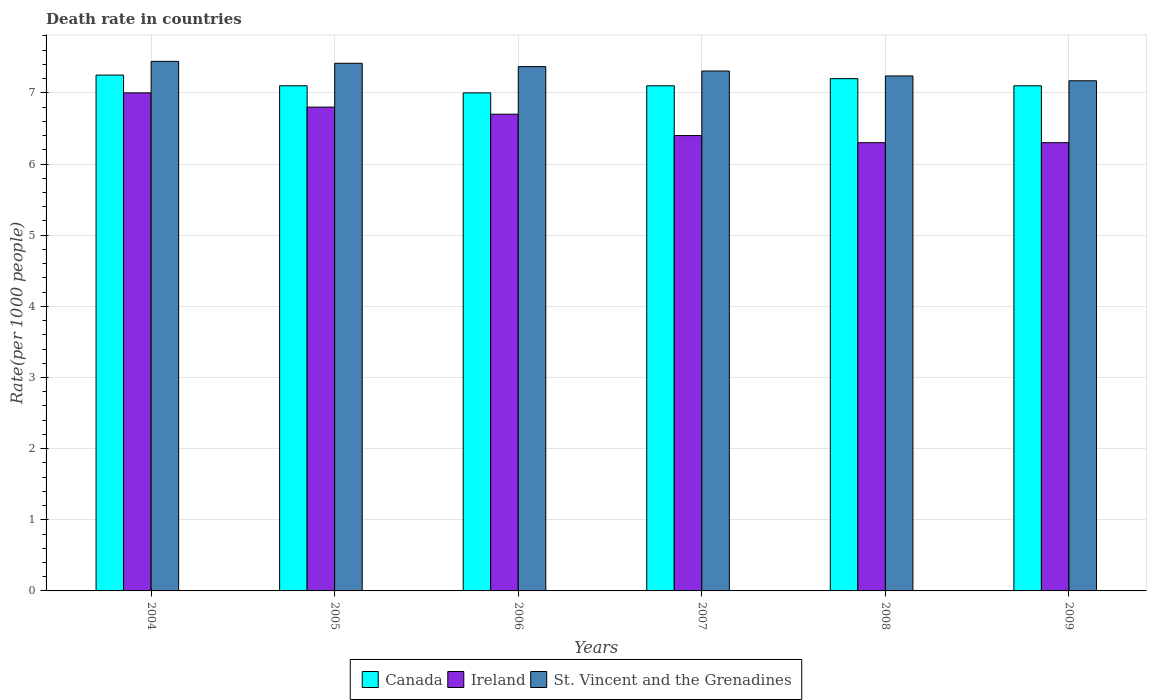How many different coloured bars are there?
Provide a short and direct response. 3. How many bars are there on the 2nd tick from the left?
Keep it short and to the point. 3. What is the death rate in St. Vincent and the Grenadines in 2007?
Make the answer very short. 7.31. In which year was the death rate in Canada minimum?
Your response must be concise. 2006. What is the total death rate in Canada in the graph?
Your answer should be compact. 42.75. What is the difference between the death rate in St. Vincent and the Grenadines in 2004 and that in 2007?
Provide a short and direct response. 0.14. What is the difference between the death rate in St. Vincent and the Grenadines in 2008 and the death rate in Canada in 2009?
Give a very brief answer. 0.14. What is the average death rate in St. Vincent and the Grenadines per year?
Offer a terse response. 7.32. In the year 2006, what is the difference between the death rate in St. Vincent and the Grenadines and death rate in Canada?
Offer a very short reply. 0.37. What is the ratio of the death rate in St. Vincent and the Grenadines in 2005 to that in 2009?
Offer a terse response. 1.03. Is the death rate in Canada in 2007 less than that in 2009?
Give a very brief answer. No. What is the difference between the highest and the second highest death rate in Ireland?
Your answer should be compact. 0.2. What is the difference between the highest and the lowest death rate in St. Vincent and the Grenadines?
Make the answer very short. 0.27. What does the 2nd bar from the left in 2009 represents?
Offer a very short reply. Ireland. What does the 2nd bar from the right in 2004 represents?
Your answer should be compact. Ireland. Are the values on the major ticks of Y-axis written in scientific E-notation?
Provide a succinct answer. No. Does the graph contain grids?
Ensure brevity in your answer.  Yes. How many legend labels are there?
Offer a very short reply. 3. How are the legend labels stacked?
Keep it short and to the point. Horizontal. What is the title of the graph?
Give a very brief answer. Death rate in countries. What is the label or title of the Y-axis?
Ensure brevity in your answer.  Rate(per 1000 people). What is the Rate(per 1000 people) in Canada in 2004?
Provide a short and direct response. 7.25. What is the Rate(per 1000 people) of St. Vincent and the Grenadines in 2004?
Offer a terse response. 7.44. What is the Rate(per 1000 people) in Canada in 2005?
Your response must be concise. 7.1. What is the Rate(per 1000 people) in St. Vincent and the Grenadines in 2005?
Offer a terse response. 7.42. What is the Rate(per 1000 people) in Ireland in 2006?
Offer a very short reply. 6.7. What is the Rate(per 1000 people) of St. Vincent and the Grenadines in 2006?
Offer a terse response. 7.37. What is the Rate(per 1000 people) in St. Vincent and the Grenadines in 2007?
Provide a succinct answer. 7.31. What is the Rate(per 1000 people) of Canada in 2008?
Provide a succinct answer. 7.2. What is the Rate(per 1000 people) in St. Vincent and the Grenadines in 2008?
Keep it short and to the point. 7.24. What is the Rate(per 1000 people) of Canada in 2009?
Provide a succinct answer. 7.1. What is the Rate(per 1000 people) of Ireland in 2009?
Provide a short and direct response. 6.3. What is the Rate(per 1000 people) of St. Vincent and the Grenadines in 2009?
Give a very brief answer. 7.17. Across all years, what is the maximum Rate(per 1000 people) of Canada?
Give a very brief answer. 7.25. Across all years, what is the maximum Rate(per 1000 people) in St. Vincent and the Grenadines?
Offer a terse response. 7.44. Across all years, what is the minimum Rate(per 1000 people) of St. Vincent and the Grenadines?
Give a very brief answer. 7.17. What is the total Rate(per 1000 people) in Canada in the graph?
Keep it short and to the point. 42.75. What is the total Rate(per 1000 people) in Ireland in the graph?
Your response must be concise. 39.5. What is the total Rate(per 1000 people) of St. Vincent and the Grenadines in the graph?
Your answer should be very brief. 43.94. What is the difference between the Rate(per 1000 people) in Ireland in 2004 and that in 2005?
Provide a short and direct response. 0.2. What is the difference between the Rate(per 1000 people) of St. Vincent and the Grenadines in 2004 and that in 2005?
Your answer should be very brief. 0.03. What is the difference between the Rate(per 1000 people) of St. Vincent and the Grenadines in 2004 and that in 2006?
Give a very brief answer. 0.07. What is the difference between the Rate(per 1000 people) of Canada in 2004 and that in 2007?
Your answer should be compact. 0.15. What is the difference between the Rate(per 1000 people) of St. Vincent and the Grenadines in 2004 and that in 2007?
Give a very brief answer. 0.14. What is the difference between the Rate(per 1000 people) of Canada in 2004 and that in 2008?
Your answer should be compact. 0.05. What is the difference between the Rate(per 1000 people) of St. Vincent and the Grenadines in 2004 and that in 2008?
Give a very brief answer. 0.2. What is the difference between the Rate(per 1000 people) in Canada in 2004 and that in 2009?
Provide a short and direct response. 0.15. What is the difference between the Rate(per 1000 people) in Ireland in 2004 and that in 2009?
Provide a succinct answer. 0.7. What is the difference between the Rate(per 1000 people) of St. Vincent and the Grenadines in 2004 and that in 2009?
Make the answer very short. 0.27. What is the difference between the Rate(per 1000 people) of Canada in 2005 and that in 2006?
Keep it short and to the point. 0.1. What is the difference between the Rate(per 1000 people) in St. Vincent and the Grenadines in 2005 and that in 2006?
Offer a very short reply. 0.05. What is the difference between the Rate(per 1000 people) in Canada in 2005 and that in 2007?
Offer a terse response. 0. What is the difference between the Rate(per 1000 people) of St. Vincent and the Grenadines in 2005 and that in 2007?
Give a very brief answer. 0.11. What is the difference between the Rate(per 1000 people) in St. Vincent and the Grenadines in 2005 and that in 2008?
Keep it short and to the point. 0.18. What is the difference between the Rate(per 1000 people) of St. Vincent and the Grenadines in 2005 and that in 2009?
Give a very brief answer. 0.25. What is the difference between the Rate(per 1000 people) in Ireland in 2006 and that in 2007?
Provide a succinct answer. 0.3. What is the difference between the Rate(per 1000 people) of St. Vincent and the Grenadines in 2006 and that in 2007?
Ensure brevity in your answer.  0.06. What is the difference between the Rate(per 1000 people) in Ireland in 2006 and that in 2008?
Offer a very short reply. 0.4. What is the difference between the Rate(per 1000 people) of St. Vincent and the Grenadines in 2006 and that in 2008?
Offer a terse response. 0.13. What is the difference between the Rate(per 1000 people) of St. Vincent and the Grenadines in 2006 and that in 2009?
Provide a short and direct response. 0.2. What is the difference between the Rate(per 1000 people) of Ireland in 2007 and that in 2008?
Make the answer very short. 0.1. What is the difference between the Rate(per 1000 people) in St. Vincent and the Grenadines in 2007 and that in 2008?
Offer a very short reply. 0.07. What is the difference between the Rate(per 1000 people) in Ireland in 2007 and that in 2009?
Ensure brevity in your answer.  0.1. What is the difference between the Rate(per 1000 people) in St. Vincent and the Grenadines in 2007 and that in 2009?
Make the answer very short. 0.14. What is the difference between the Rate(per 1000 people) in Canada in 2008 and that in 2009?
Give a very brief answer. 0.1. What is the difference between the Rate(per 1000 people) in Ireland in 2008 and that in 2009?
Provide a short and direct response. 0. What is the difference between the Rate(per 1000 people) of St. Vincent and the Grenadines in 2008 and that in 2009?
Give a very brief answer. 0.07. What is the difference between the Rate(per 1000 people) in Canada in 2004 and the Rate(per 1000 people) in Ireland in 2005?
Provide a succinct answer. 0.45. What is the difference between the Rate(per 1000 people) of Canada in 2004 and the Rate(per 1000 people) of St. Vincent and the Grenadines in 2005?
Your answer should be compact. -0.17. What is the difference between the Rate(per 1000 people) in Ireland in 2004 and the Rate(per 1000 people) in St. Vincent and the Grenadines in 2005?
Keep it short and to the point. -0.42. What is the difference between the Rate(per 1000 people) in Canada in 2004 and the Rate(per 1000 people) in Ireland in 2006?
Your response must be concise. 0.55. What is the difference between the Rate(per 1000 people) of Canada in 2004 and the Rate(per 1000 people) of St. Vincent and the Grenadines in 2006?
Your answer should be compact. -0.12. What is the difference between the Rate(per 1000 people) of Ireland in 2004 and the Rate(per 1000 people) of St. Vincent and the Grenadines in 2006?
Offer a terse response. -0.37. What is the difference between the Rate(per 1000 people) of Canada in 2004 and the Rate(per 1000 people) of St. Vincent and the Grenadines in 2007?
Offer a terse response. -0.06. What is the difference between the Rate(per 1000 people) in Ireland in 2004 and the Rate(per 1000 people) in St. Vincent and the Grenadines in 2007?
Your answer should be compact. -0.31. What is the difference between the Rate(per 1000 people) in Canada in 2004 and the Rate(per 1000 people) in St. Vincent and the Grenadines in 2008?
Offer a very short reply. 0.01. What is the difference between the Rate(per 1000 people) of Ireland in 2004 and the Rate(per 1000 people) of St. Vincent and the Grenadines in 2008?
Your answer should be compact. -0.24. What is the difference between the Rate(per 1000 people) of Canada in 2004 and the Rate(per 1000 people) of St. Vincent and the Grenadines in 2009?
Your response must be concise. 0.08. What is the difference between the Rate(per 1000 people) in Ireland in 2004 and the Rate(per 1000 people) in St. Vincent and the Grenadines in 2009?
Your answer should be very brief. -0.17. What is the difference between the Rate(per 1000 people) of Canada in 2005 and the Rate(per 1000 people) of St. Vincent and the Grenadines in 2006?
Your answer should be very brief. -0.27. What is the difference between the Rate(per 1000 people) in Ireland in 2005 and the Rate(per 1000 people) in St. Vincent and the Grenadines in 2006?
Provide a short and direct response. -0.57. What is the difference between the Rate(per 1000 people) in Canada in 2005 and the Rate(per 1000 people) in Ireland in 2007?
Keep it short and to the point. 0.7. What is the difference between the Rate(per 1000 people) in Canada in 2005 and the Rate(per 1000 people) in St. Vincent and the Grenadines in 2007?
Provide a succinct answer. -0.21. What is the difference between the Rate(per 1000 people) in Ireland in 2005 and the Rate(per 1000 people) in St. Vincent and the Grenadines in 2007?
Offer a very short reply. -0.51. What is the difference between the Rate(per 1000 people) in Canada in 2005 and the Rate(per 1000 people) in Ireland in 2008?
Provide a succinct answer. 0.8. What is the difference between the Rate(per 1000 people) of Canada in 2005 and the Rate(per 1000 people) of St. Vincent and the Grenadines in 2008?
Your answer should be very brief. -0.14. What is the difference between the Rate(per 1000 people) of Ireland in 2005 and the Rate(per 1000 people) of St. Vincent and the Grenadines in 2008?
Give a very brief answer. -0.44. What is the difference between the Rate(per 1000 people) in Canada in 2005 and the Rate(per 1000 people) in St. Vincent and the Grenadines in 2009?
Your answer should be very brief. -0.07. What is the difference between the Rate(per 1000 people) in Ireland in 2005 and the Rate(per 1000 people) in St. Vincent and the Grenadines in 2009?
Your answer should be very brief. -0.37. What is the difference between the Rate(per 1000 people) of Canada in 2006 and the Rate(per 1000 people) of St. Vincent and the Grenadines in 2007?
Provide a succinct answer. -0.31. What is the difference between the Rate(per 1000 people) in Ireland in 2006 and the Rate(per 1000 people) in St. Vincent and the Grenadines in 2007?
Offer a very short reply. -0.61. What is the difference between the Rate(per 1000 people) of Canada in 2006 and the Rate(per 1000 people) of St. Vincent and the Grenadines in 2008?
Offer a terse response. -0.24. What is the difference between the Rate(per 1000 people) of Ireland in 2006 and the Rate(per 1000 people) of St. Vincent and the Grenadines in 2008?
Give a very brief answer. -0.54. What is the difference between the Rate(per 1000 people) in Canada in 2006 and the Rate(per 1000 people) in St. Vincent and the Grenadines in 2009?
Ensure brevity in your answer.  -0.17. What is the difference between the Rate(per 1000 people) in Ireland in 2006 and the Rate(per 1000 people) in St. Vincent and the Grenadines in 2009?
Offer a terse response. -0.47. What is the difference between the Rate(per 1000 people) in Canada in 2007 and the Rate(per 1000 people) in Ireland in 2008?
Offer a very short reply. 0.8. What is the difference between the Rate(per 1000 people) in Canada in 2007 and the Rate(per 1000 people) in St. Vincent and the Grenadines in 2008?
Keep it short and to the point. -0.14. What is the difference between the Rate(per 1000 people) in Ireland in 2007 and the Rate(per 1000 people) in St. Vincent and the Grenadines in 2008?
Provide a short and direct response. -0.84. What is the difference between the Rate(per 1000 people) of Canada in 2007 and the Rate(per 1000 people) of St. Vincent and the Grenadines in 2009?
Offer a terse response. -0.07. What is the difference between the Rate(per 1000 people) of Ireland in 2007 and the Rate(per 1000 people) of St. Vincent and the Grenadines in 2009?
Your answer should be compact. -0.77. What is the difference between the Rate(per 1000 people) in Ireland in 2008 and the Rate(per 1000 people) in St. Vincent and the Grenadines in 2009?
Provide a short and direct response. -0.87. What is the average Rate(per 1000 people) in Canada per year?
Give a very brief answer. 7.12. What is the average Rate(per 1000 people) in Ireland per year?
Offer a terse response. 6.58. What is the average Rate(per 1000 people) of St. Vincent and the Grenadines per year?
Keep it short and to the point. 7.32. In the year 2004, what is the difference between the Rate(per 1000 people) in Canada and Rate(per 1000 people) in Ireland?
Ensure brevity in your answer.  0.25. In the year 2004, what is the difference between the Rate(per 1000 people) of Canada and Rate(per 1000 people) of St. Vincent and the Grenadines?
Give a very brief answer. -0.19. In the year 2004, what is the difference between the Rate(per 1000 people) of Ireland and Rate(per 1000 people) of St. Vincent and the Grenadines?
Your response must be concise. -0.44. In the year 2005, what is the difference between the Rate(per 1000 people) of Canada and Rate(per 1000 people) of Ireland?
Give a very brief answer. 0.3. In the year 2005, what is the difference between the Rate(per 1000 people) in Canada and Rate(per 1000 people) in St. Vincent and the Grenadines?
Your response must be concise. -0.32. In the year 2005, what is the difference between the Rate(per 1000 people) of Ireland and Rate(per 1000 people) of St. Vincent and the Grenadines?
Give a very brief answer. -0.62. In the year 2006, what is the difference between the Rate(per 1000 people) of Canada and Rate(per 1000 people) of St. Vincent and the Grenadines?
Keep it short and to the point. -0.37. In the year 2006, what is the difference between the Rate(per 1000 people) of Ireland and Rate(per 1000 people) of St. Vincent and the Grenadines?
Offer a terse response. -0.67. In the year 2007, what is the difference between the Rate(per 1000 people) in Canada and Rate(per 1000 people) in St. Vincent and the Grenadines?
Offer a terse response. -0.21. In the year 2007, what is the difference between the Rate(per 1000 people) of Ireland and Rate(per 1000 people) of St. Vincent and the Grenadines?
Ensure brevity in your answer.  -0.91. In the year 2008, what is the difference between the Rate(per 1000 people) of Canada and Rate(per 1000 people) of St. Vincent and the Grenadines?
Provide a succinct answer. -0.04. In the year 2008, what is the difference between the Rate(per 1000 people) of Ireland and Rate(per 1000 people) of St. Vincent and the Grenadines?
Your response must be concise. -0.94. In the year 2009, what is the difference between the Rate(per 1000 people) in Canada and Rate(per 1000 people) in Ireland?
Offer a very short reply. 0.8. In the year 2009, what is the difference between the Rate(per 1000 people) in Canada and Rate(per 1000 people) in St. Vincent and the Grenadines?
Offer a very short reply. -0.07. In the year 2009, what is the difference between the Rate(per 1000 people) in Ireland and Rate(per 1000 people) in St. Vincent and the Grenadines?
Provide a short and direct response. -0.87. What is the ratio of the Rate(per 1000 people) in Canada in 2004 to that in 2005?
Your answer should be compact. 1.02. What is the ratio of the Rate(per 1000 people) in Ireland in 2004 to that in 2005?
Ensure brevity in your answer.  1.03. What is the ratio of the Rate(per 1000 people) of St. Vincent and the Grenadines in 2004 to that in 2005?
Provide a short and direct response. 1. What is the ratio of the Rate(per 1000 people) in Canada in 2004 to that in 2006?
Offer a terse response. 1.04. What is the ratio of the Rate(per 1000 people) in Ireland in 2004 to that in 2006?
Provide a short and direct response. 1.04. What is the ratio of the Rate(per 1000 people) of St. Vincent and the Grenadines in 2004 to that in 2006?
Your response must be concise. 1.01. What is the ratio of the Rate(per 1000 people) in Canada in 2004 to that in 2007?
Your answer should be compact. 1.02. What is the ratio of the Rate(per 1000 people) in Ireland in 2004 to that in 2007?
Your answer should be very brief. 1.09. What is the ratio of the Rate(per 1000 people) of St. Vincent and the Grenadines in 2004 to that in 2007?
Offer a very short reply. 1.02. What is the ratio of the Rate(per 1000 people) of Canada in 2004 to that in 2008?
Provide a short and direct response. 1.01. What is the ratio of the Rate(per 1000 people) of St. Vincent and the Grenadines in 2004 to that in 2008?
Provide a succinct answer. 1.03. What is the ratio of the Rate(per 1000 people) in Canada in 2004 to that in 2009?
Your response must be concise. 1.02. What is the ratio of the Rate(per 1000 people) in Ireland in 2004 to that in 2009?
Provide a short and direct response. 1.11. What is the ratio of the Rate(per 1000 people) of St. Vincent and the Grenadines in 2004 to that in 2009?
Keep it short and to the point. 1.04. What is the ratio of the Rate(per 1000 people) in Canada in 2005 to that in 2006?
Offer a terse response. 1.01. What is the ratio of the Rate(per 1000 people) of Ireland in 2005 to that in 2006?
Provide a succinct answer. 1.01. What is the ratio of the Rate(per 1000 people) of St. Vincent and the Grenadines in 2005 to that in 2006?
Make the answer very short. 1.01. What is the ratio of the Rate(per 1000 people) in Ireland in 2005 to that in 2007?
Your answer should be very brief. 1.06. What is the ratio of the Rate(per 1000 people) of St. Vincent and the Grenadines in 2005 to that in 2007?
Provide a succinct answer. 1.01. What is the ratio of the Rate(per 1000 people) in Canada in 2005 to that in 2008?
Your answer should be very brief. 0.99. What is the ratio of the Rate(per 1000 people) of Ireland in 2005 to that in 2008?
Your response must be concise. 1.08. What is the ratio of the Rate(per 1000 people) of St. Vincent and the Grenadines in 2005 to that in 2008?
Ensure brevity in your answer.  1.02. What is the ratio of the Rate(per 1000 people) in Ireland in 2005 to that in 2009?
Provide a short and direct response. 1.08. What is the ratio of the Rate(per 1000 people) of St. Vincent and the Grenadines in 2005 to that in 2009?
Your response must be concise. 1.03. What is the ratio of the Rate(per 1000 people) in Canada in 2006 to that in 2007?
Give a very brief answer. 0.99. What is the ratio of the Rate(per 1000 people) of Ireland in 2006 to that in 2007?
Provide a succinct answer. 1.05. What is the ratio of the Rate(per 1000 people) of St. Vincent and the Grenadines in 2006 to that in 2007?
Provide a succinct answer. 1.01. What is the ratio of the Rate(per 1000 people) in Canada in 2006 to that in 2008?
Keep it short and to the point. 0.97. What is the ratio of the Rate(per 1000 people) of Ireland in 2006 to that in 2008?
Make the answer very short. 1.06. What is the ratio of the Rate(per 1000 people) of St. Vincent and the Grenadines in 2006 to that in 2008?
Your answer should be very brief. 1.02. What is the ratio of the Rate(per 1000 people) in Canada in 2006 to that in 2009?
Your answer should be compact. 0.99. What is the ratio of the Rate(per 1000 people) in Ireland in 2006 to that in 2009?
Your answer should be compact. 1.06. What is the ratio of the Rate(per 1000 people) of St. Vincent and the Grenadines in 2006 to that in 2009?
Ensure brevity in your answer.  1.03. What is the ratio of the Rate(per 1000 people) of Canada in 2007 to that in 2008?
Offer a very short reply. 0.99. What is the ratio of the Rate(per 1000 people) in Ireland in 2007 to that in 2008?
Your response must be concise. 1.02. What is the ratio of the Rate(per 1000 people) of St. Vincent and the Grenadines in 2007 to that in 2008?
Provide a short and direct response. 1.01. What is the ratio of the Rate(per 1000 people) of Ireland in 2007 to that in 2009?
Offer a terse response. 1.02. What is the ratio of the Rate(per 1000 people) of St. Vincent and the Grenadines in 2007 to that in 2009?
Your answer should be compact. 1.02. What is the ratio of the Rate(per 1000 people) of Canada in 2008 to that in 2009?
Your response must be concise. 1.01. What is the ratio of the Rate(per 1000 people) in St. Vincent and the Grenadines in 2008 to that in 2009?
Offer a very short reply. 1.01. What is the difference between the highest and the second highest Rate(per 1000 people) in Canada?
Provide a succinct answer. 0.05. What is the difference between the highest and the second highest Rate(per 1000 people) in Ireland?
Make the answer very short. 0.2. What is the difference between the highest and the second highest Rate(per 1000 people) of St. Vincent and the Grenadines?
Make the answer very short. 0.03. What is the difference between the highest and the lowest Rate(per 1000 people) in Canada?
Your response must be concise. 0.25. What is the difference between the highest and the lowest Rate(per 1000 people) in Ireland?
Make the answer very short. 0.7. What is the difference between the highest and the lowest Rate(per 1000 people) of St. Vincent and the Grenadines?
Offer a terse response. 0.27. 